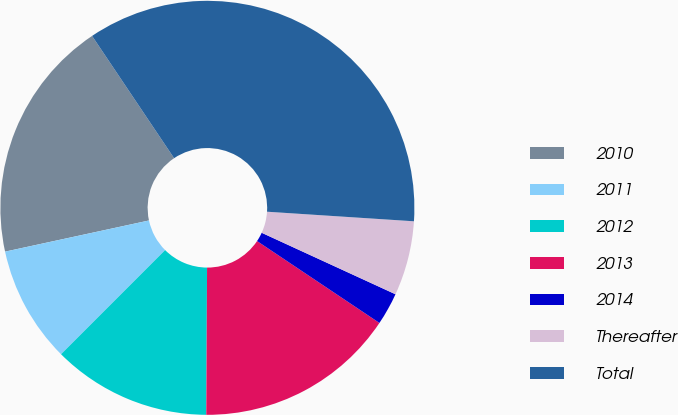<chart> <loc_0><loc_0><loc_500><loc_500><pie_chart><fcel>2010<fcel>2011<fcel>2012<fcel>2013<fcel>2014<fcel>Thereafter<fcel>Total<nl><fcel>18.99%<fcel>9.11%<fcel>12.41%<fcel>15.7%<fcel>2.53%<fcel>5.82%<fcel>35.44%<nl></chart> 